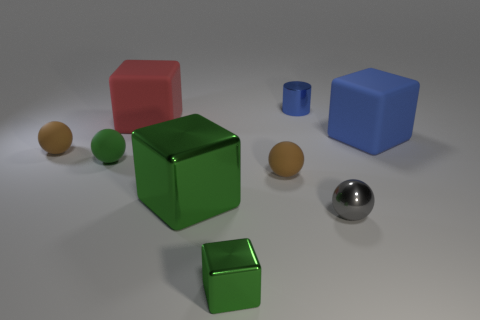What is the texture of the objects like, and does the surface they're on have any texture? The objects have a smooth texture, with specular highlights suggesting they are somewhat reflective. The surface beneath them seems to be matte, with a subtle graininess that contrasts with the sleekness of the objects. 